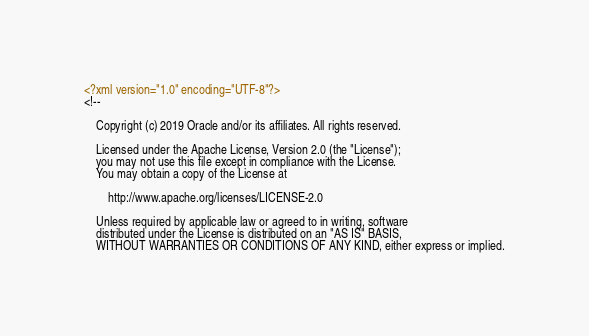Convert code to text. <code><loc_0><loc_0><loc_500><loc_500><_XML_><?xml version="1.0" encoding="UTF-8"?>
<!--

    Copyright (c) 2019 Oracle and/or its affiliates. All rights reserved.

    Licensed under the Apache License, Version 2.0 (the "License");
    you may not use this file except in compliance with the License.
    You may obtain a copy of the License at

        http://www.apache.org/licenses/LICENSE-2.0

    Unless required by applicable law or agreed to in writing, software
    distributed under the License is distributed on an "AS IS" BASIS,
    WITHOUT WARRANTIES OR CONDITIONS OF ANY KIND, either express or implied.</code> 